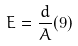<formula> <loc_0><loc_0><loc_500><loc_500>E = \frac { d } { A } ( 9 )</formula> 